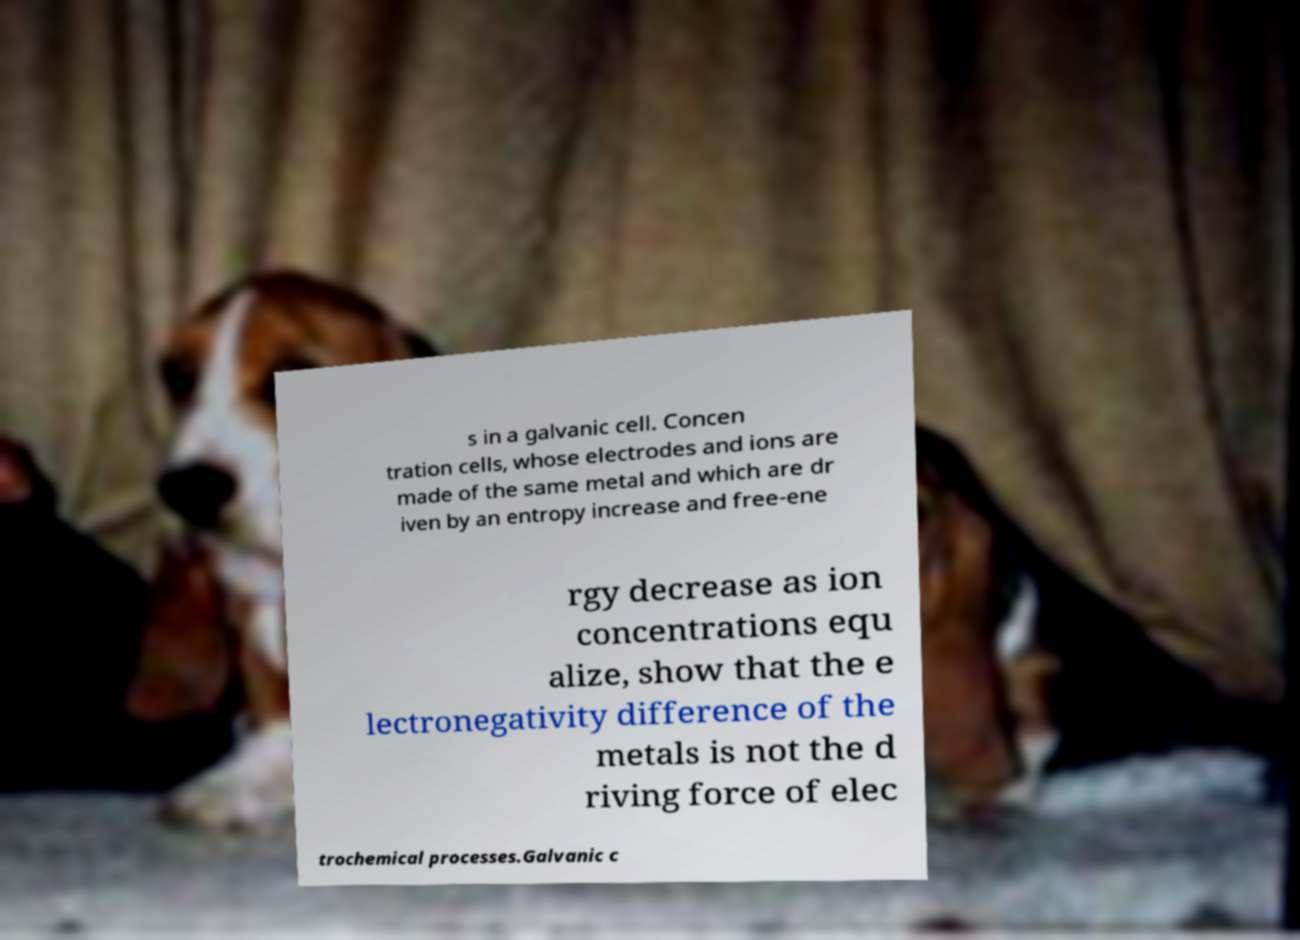What messages or text are displayed in this image? I need them in a readable, typed format. s in a galvanic cell. Concen tration cells, whose electrodes and ions are made of the same metal and which are dr iven by an entropy increase and free-ene rgy decrease as ion concentrations equ alize, show that the e lectronegativity difference of the metals is not the d riving force of elec trochemical processes.Galvanic c 